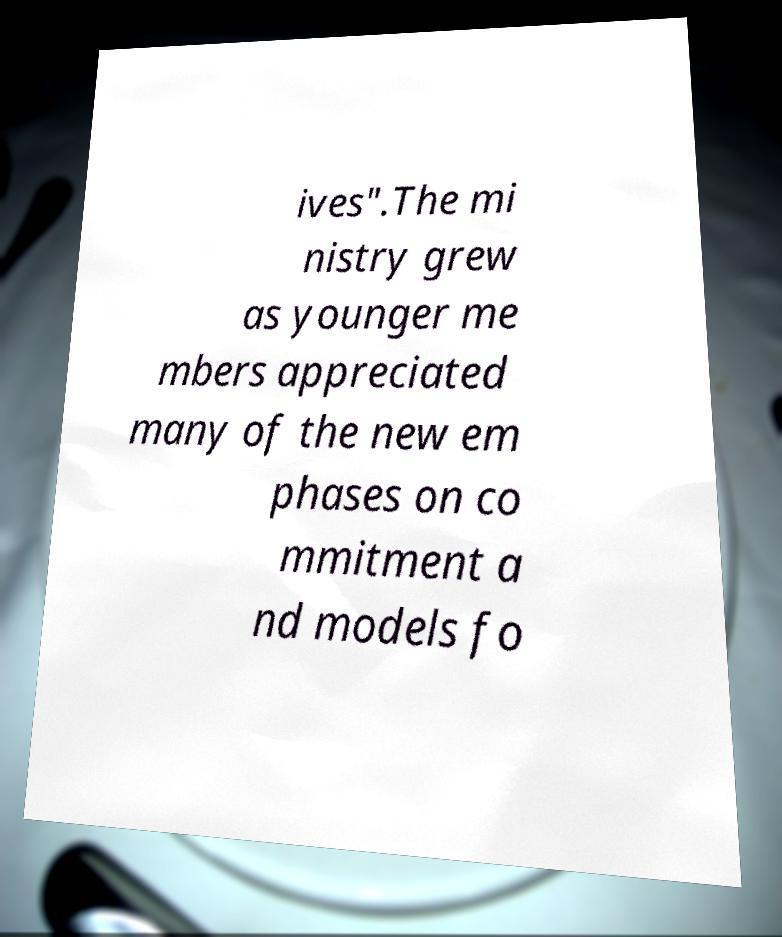There's text embedded in this image that I need extracted. Can you transcribe it verbatim? ives".The mi nistry grew as younger me mbers appreciated many of the new em phases on co mmitment a nd models fo 